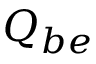<formula> <loc_0><loc_0><loc_500><loc_500>Q _ { b e }</formula> 